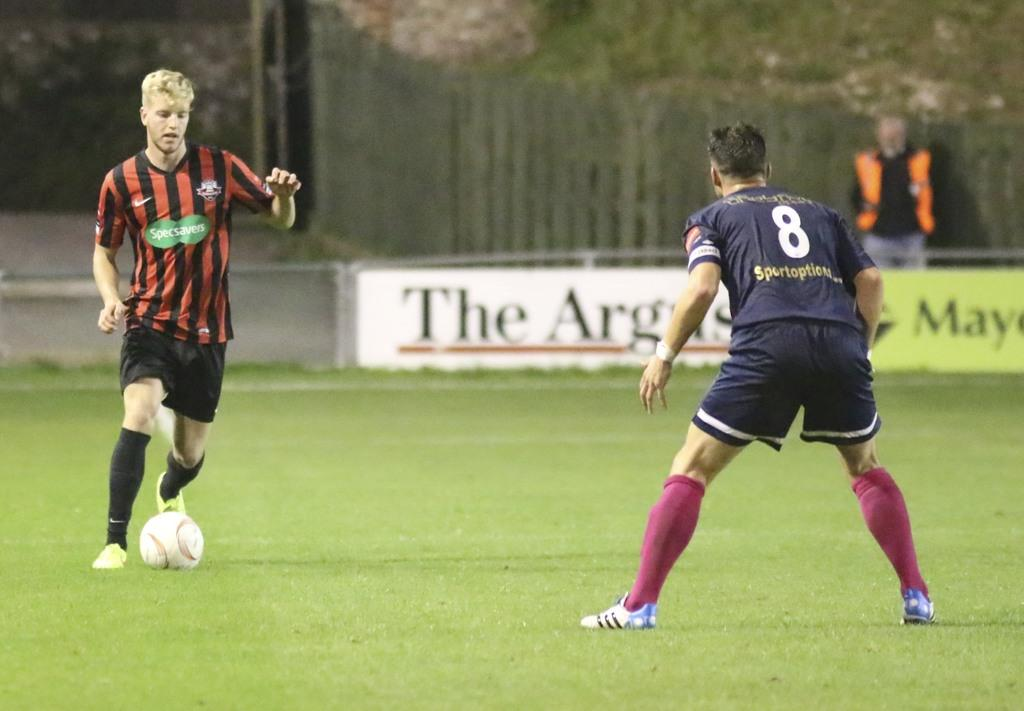Provide a one-sentence caption for the provided image. A man in a striped jersey is sponsored by Specsavers. 